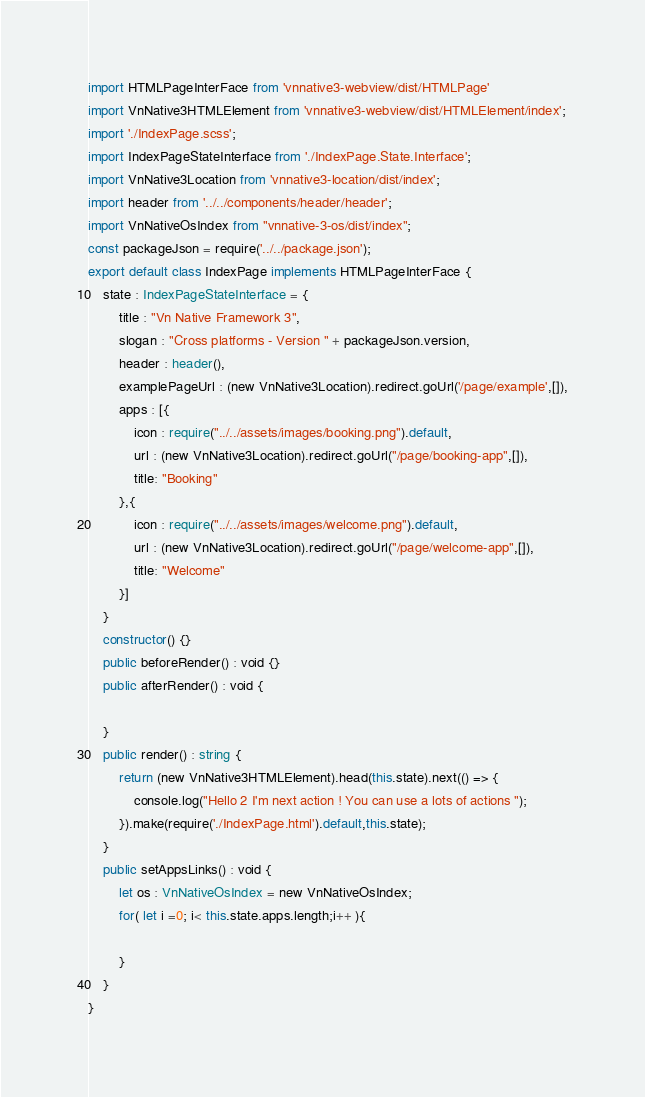<code> <loc_0><loc_0><loc_500><loc_500><_TypeScript_>import HTMLPageInterFace from 'vnnative3-webview/dist/HTMLPage'
import VnNative3HTMLElement from 'vnnative3-webview/dist/HTMLElement/index';
import './IndexPage.scss';
import IndexPageStateInterface from './IndexPage.State.Interface';
import VnNative3Location from 'vnnative3-location/dist/index';
import header from '../../components/header/header';
import VnNativeOsIndex from "vnnative-3-os/dist/index";
const packageJson = require('../../package.json');
export default class IndexPage implements HTMLPageInterFace {
    state : IndexPageStateInterface = {
        title : "Vn Native Framework 3",
        slogan : "Cross platforms - Version " + packageJson.version,
        header : header(), 
        examplePageUrl : (new VnNative3Location).redirect.goUrl('/page/example',[]),
        apps : [{
            icon : require("../../assets/images/booking.png").default,
            url : (new VnNative3Location).redirect.goUrl("/page/booking-app",[]),
            title: "Booking"
        },{
            icon : require("../../assets/images/welcome.png").default,
            url : (new VnNative3Location).redirect.goUrl("/page/welcome-app",[]),
            title: "Welcome"
        }]
    }
    constructor() {}      
    public beforeRender() : void {}  
    public afterRender() : void {
        
    }     
    public render() : string { 
        return (new VnNative3HTMLElement).head(this.state).next(() => {
            console.log("Hello 2 I'm next action ! You can use a lots of actions ");
        }).make(require('./IndexPage.html').default,this.state); 
    }  
    public setAppsLinks() : void {
        let os : VnNativeOsIndex = new VnNativeOsIndex;
        for( let i =0; i< this.state.apps.length;i++ ){
            
        } 
    }
}              </code> 